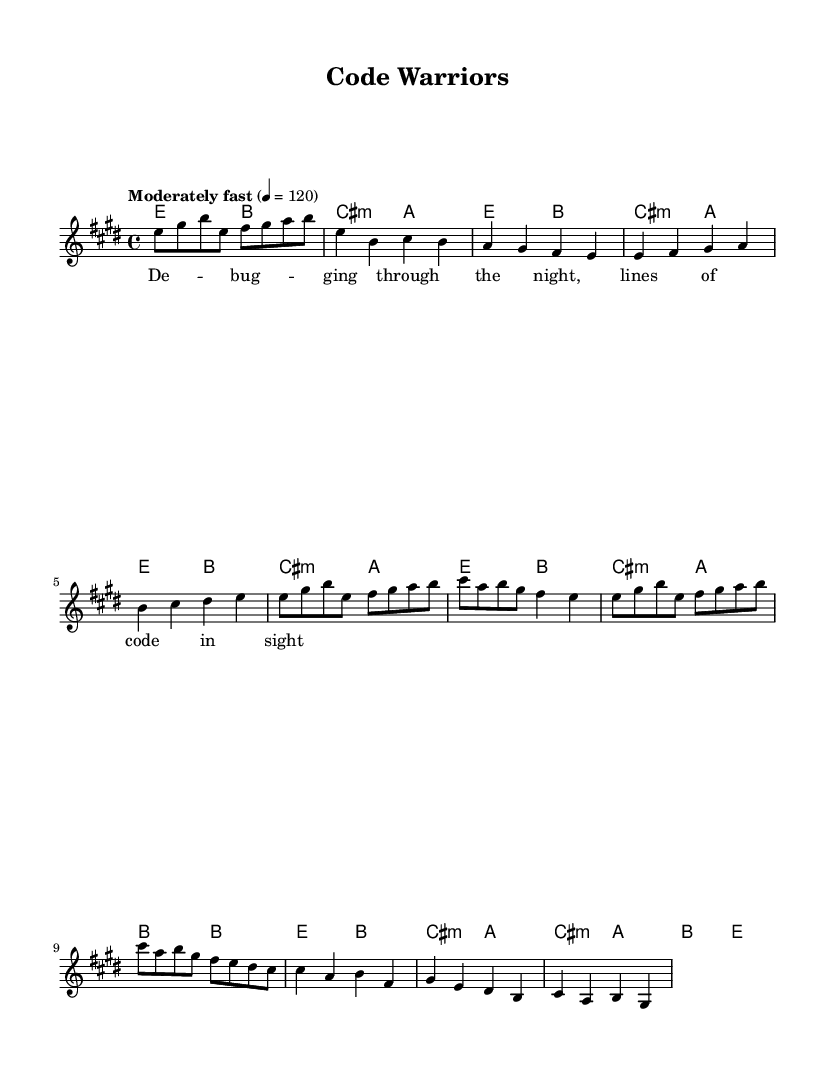What is the key signature of this music? The key signature shows two sharps (F# and C#) indicating that the piece is in E major.
Answer: E major What is the time signature of this piece? The time signature displayed is 4/4, which means there are four beats in each measure, and a quarter note gets one beat.
Answer: 4/4 What is the tempo marking for this music? The tempo indicates "Moderately fast" with a tempo marking of 120 beats per minute, guiding the performer on the pace of the piece.
Answer: Moderately fast How many measures are in the written melody? By counting the measures presented in the melody section, there are a total of 14 measures indicated.
Answer: 14 What is the first lyric phrase in the verse? The first lyric line reads "Debugging through the night," which corresponds to the first melody line in the verse.
Answer: Debugging through the night What is the last chord in the bridge section? The last chord notated in the bridge section is an E major chord, indicating a resolution in the progression.
Answer: E What is the title of this composition? The title displayed at the top of the sheet music is "Code Warriors," which reflects the theme of perseverance in the face of challenges.
Answer: Code Warriors 